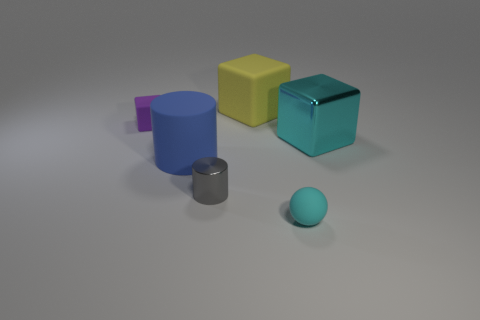Subtract all big blocks. How many blocks are left? 1 Subtract all purple cubes. How many cubes are left? 2 Subtract 2 cylinders. How many cylinders are left? 0 Add 2 large blue matte cylinders. How many objects exist? 8 Add 2 metal cubes. How many metal cubes are left? 3 Add 6 large yellow shiny cylinders. How many large yellow shiny cylinders exist? 6 Subtract 1 yellow cubes. How many objects are left? 5 Subtract all cylinders. How many objects are left? 4 Subtract all blue blocks. Subtract all brown spheres. How many blocks are left? 3 Subtract all gray cubes. How many blue cylinders are left? 1 